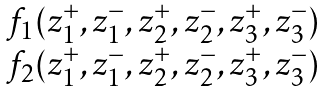Convert formula to latex. <formula><loc_0><loc_0><loc_500><loc_500>\begin{matrix} f _ { 1 } ( z _ { 1 } ^ { + } , z _ { 1 } ^ { - } , z _ { 2 } ^ { + } , z _ { 2 } ^ { - } , z _ { 3 } ^ { + } , z _ { 3 } ^ { - } ) \\ f _ { 2 } ( z _ { 1 } ^ { + } , z _ { 1 } ^ { - } , z _ { 2 } ^ { + } , z _ { 2 } ^ { - } , z _ { 3 } ^ { + } , z _ { 3 } ^ { - } ) \end{matrix}</formula> 